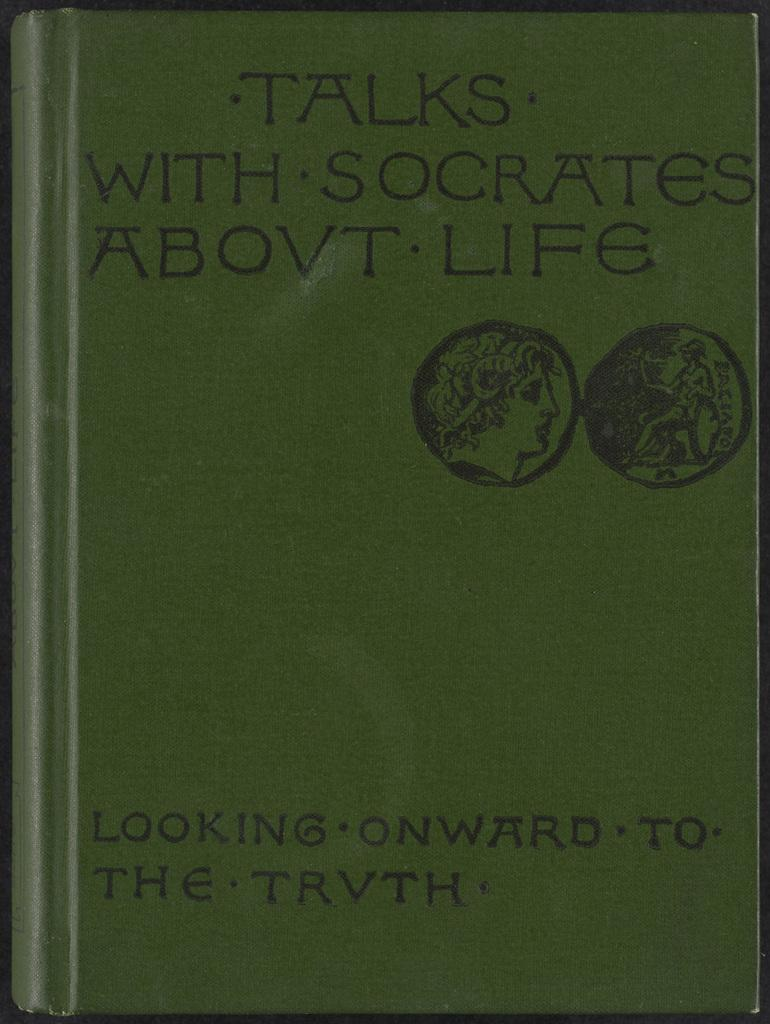What is depicted on the book cover in the image? There is a book cover in the image. What material is the book cover made of? The book cover is made of paper. What color is the book in the image? The book is green in color. Is there any text or design on the book cover? Yes, there is writing on the book cover. What type of underwear is the woman wearing in the image? There is no woman or underwear present in the image; it only features a book cover. 